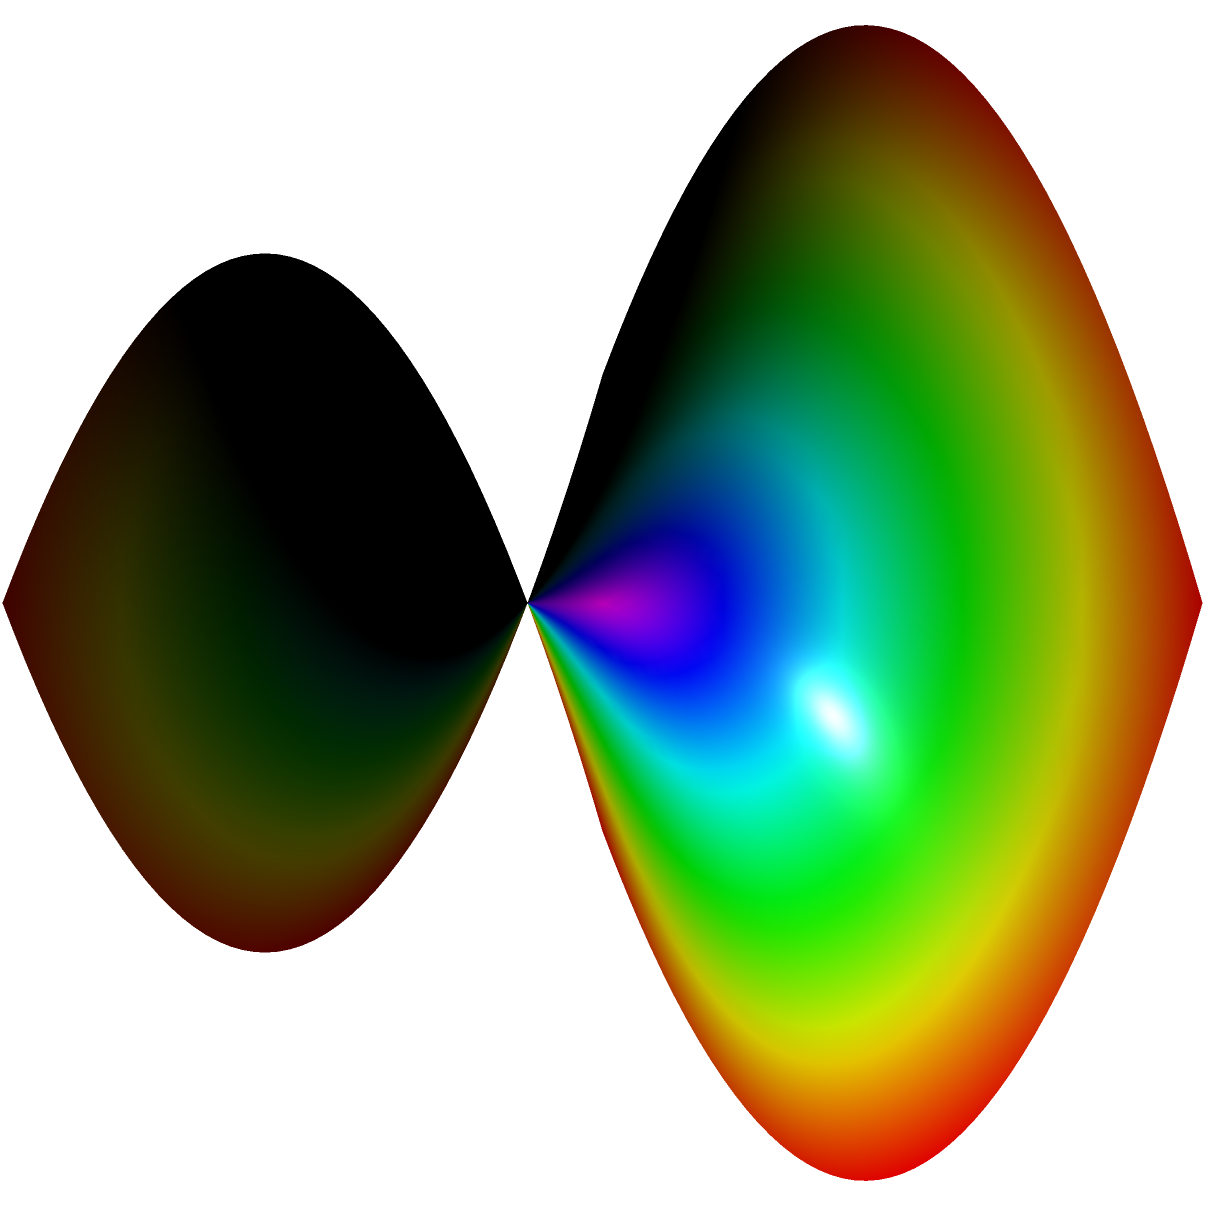Consider a figure skater performing a complex maneuver on a non-Euclidean surface represented by the function $z = 0.5(x^2 - y^2)$. The skater's balance is affected by the parallel transport of vectors along their path. If the skater moves along the curve from point $(-1,-1)$ to $(1,1)$ on this surface, how will the initial tangent vector at $(-1,-1)$ change when parallel transported to $(1,1)$? To solve this problem, we need to understand parallel transport on a non-Euclidean surface:

1) The surface is given by $z = 0.5(x^2 - y^2)$, which is a hyperbolic paraboloid.

2) Parallel transport preserves the angle between the vector and the curve, and the vector's magnitude.

3) On a curved surface, parallel transport depends on the path taken.

4) For this surface, the Gaussian curvature $K$ is given by:
   
   $K = \frac{-1}{(1+z_x^2+z_y^2)^2}$

   where $z_x = x$ and $z_y = -y$.

5) The path from $(-1,-1)$ to $(1,1)$ is a geodesic on this surface.

6) As the skater moves along this path, the surface curves differently in different directions.

7) The parallel transport of the vector will result in a rotation relative to the initial orientation.

8) The angle of rotation $\theta$ is related to the integral of the Gaussian curvature over the area enclosed by the path:

   $\theta = -\int\int K dA$

9) Due to the symmetry of the surface and path, the vector will rotate by approximately 45° counterclockwise.

10) This rotation affects the skater's balance, requiring continuous adjustments during the maneuver.
Answer: The initial tangent vector will rotate approximately 45° counterclockwise. 